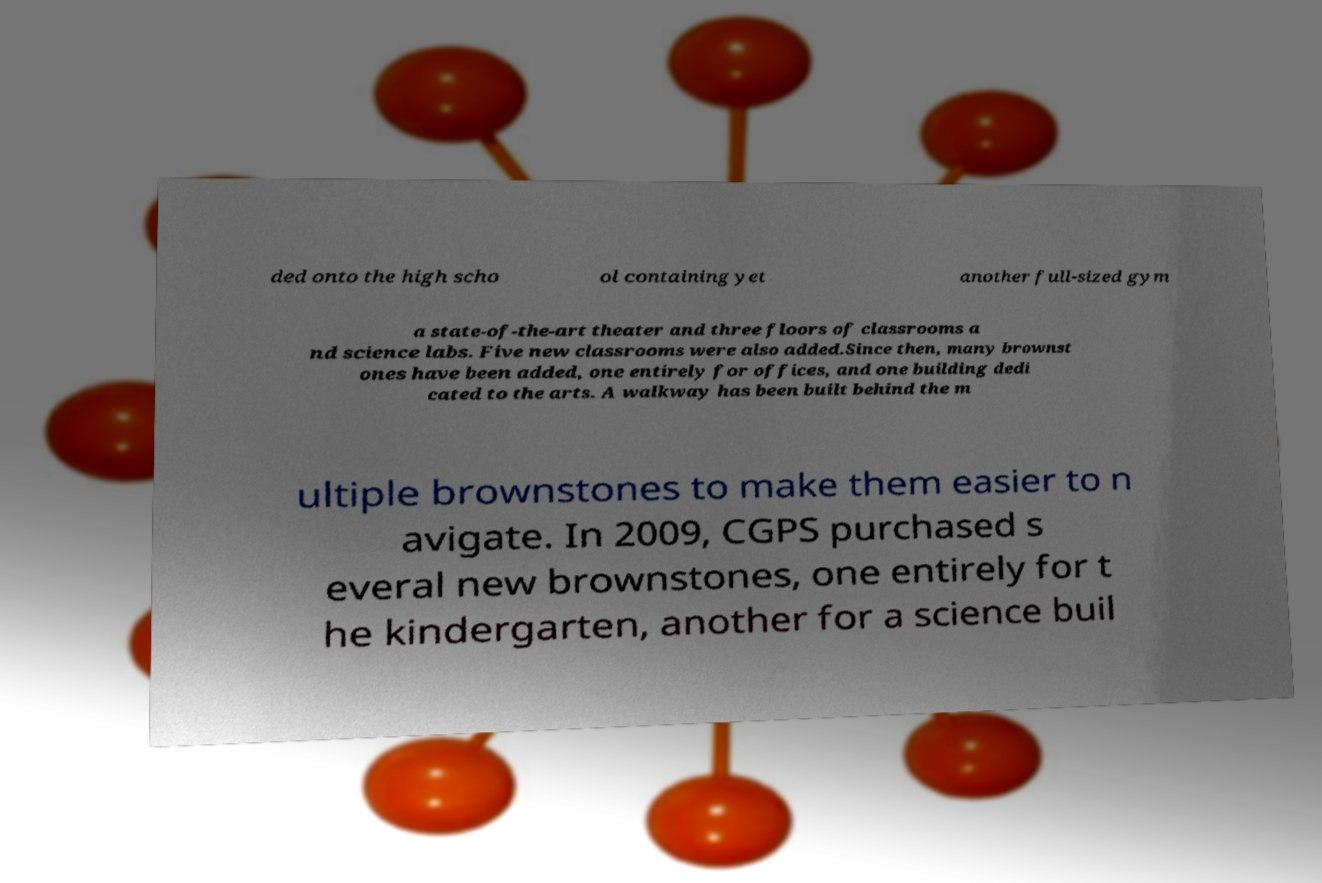I need the written content from this picture converted into text. Can you do that? ded onto the high scho ol containing yet another full-sized gym a state-of-the-art theater and three floors of classrooms a nd science labs. Five new classrooms were also added.Since then, many brownst ones have been added, one entirely for offices, and one building dedi cated to the arts. A walkway has been built behind the m ultiple brownstones to make them easier to n avigate. In 2009, CGPS purchased s everal new brownstones, one entirely for t he kindergarten, another for a science buil 